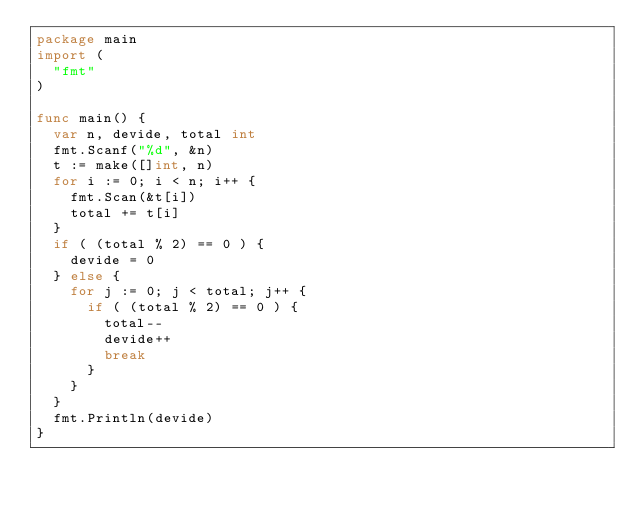Convert code to text. <code><loc_0><loc_0><loc_500><loc_500><_Go_>package main
import (
  "fmt"
)

func main() {
  var n, devide, total int
  fmt.Scanf("%d", &n)
  t := make([]int, n)
  for i := 0; i < n; i++ {
  	fmt.Scan(&t[i])
    total += t[i]
  }
  if ( (total % 2) == 0 ) {
    devide = 0
  } else {
    for j := 0; j < total; j++ {
      if ( (total % 2) == 0 ) {
        total--
        devide++
        break
      }
    }
  }
  fmt.Println(devide)
}</code> 